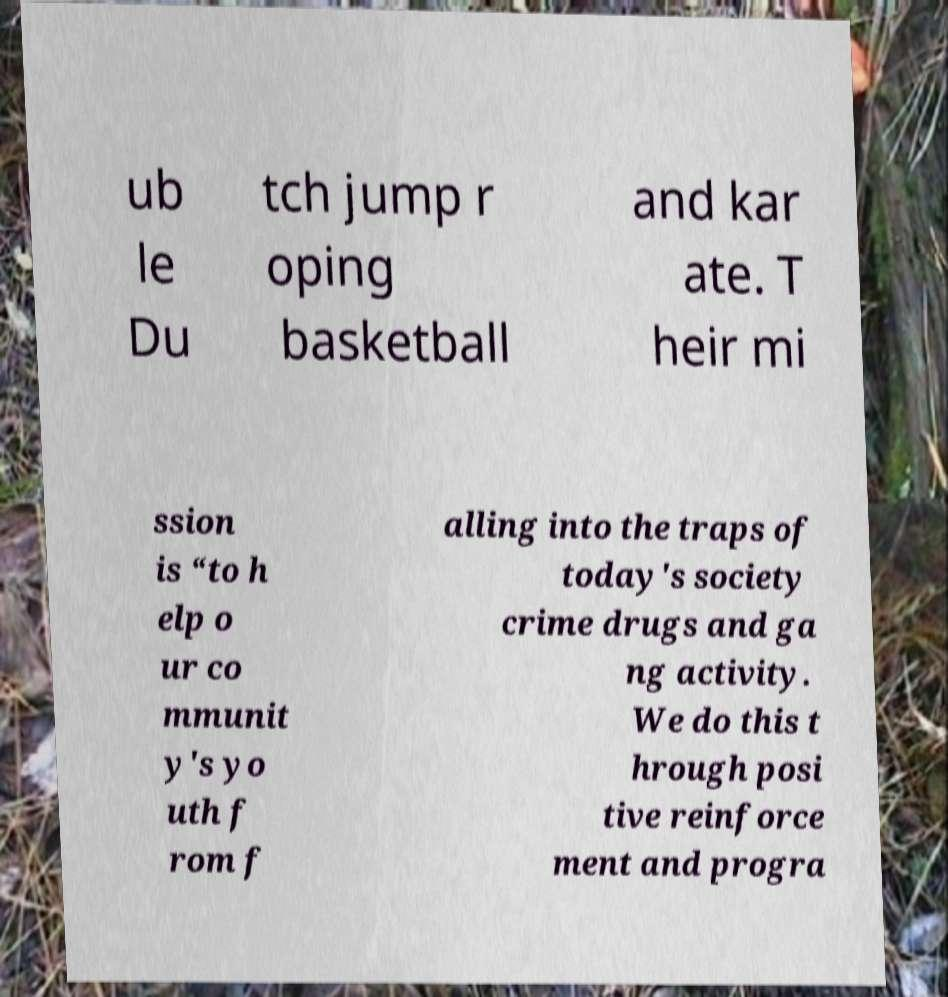What messages or text are displayed in this image? I need them in a readable, typed format. ub le Du tch jump r oping basketball and kar ate. T heir mi ssion is “to h elp o ur co mmunit y's yo uth f rom f alling into the traps of today's society crime drugs and ga ng activity. We do this t hrough posi tive reinforce ment and progra 